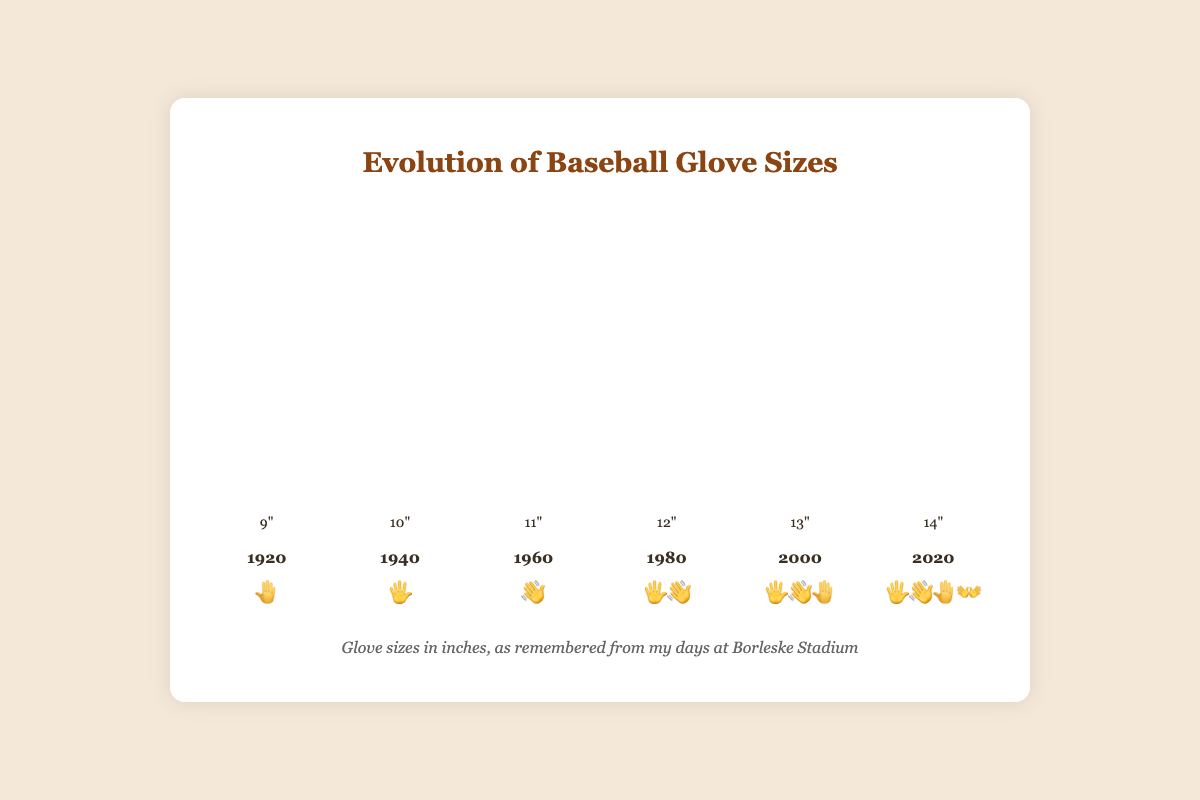Which year has the smallest glove size? The bar representing the year 1920 has the smallest height among all other bars, and the glove size is labeled as 9 inches.
Answer: 1920 What is the range of glove sizes shown in the chart from the smallest to the largest? The smallest glove size is 9 inches (1920) and the largest is 14 inches (2020). The range is calculated as 14 - 9.
Answer: 5 inches In which decade did the glove size reach 12 inches? The glove size reached 12 inches in the decade of 1980, as shown by the bar labeled with a height corresponding to 12 inches.
Answer: 1980 How many years are displayed on the chart? Counting the individual major year labels, the chart shows data for the years 1920, 1940, 1960, 1980, 2000, and 2020.
Answer: 6 years What does the glove size reach in the year 2020? The glove size in 2020 is marked on the bar, which reaches 14 inches, and is shown with the emoji combination 🖐️👋🤚👐.
Answer: 14 inches Which year has a glove size of 11 inches? The bar representing the year 1960 has a height corresponding to 11 inches, and the emoji near it is 👋.
Answer: 1960 How much did the glove size increase from 1940 to 1960? The glove size increased from 10 inches in 1940 to 11 inches in 1960. The increase is calculated as 11 - 10.
Answer: 1 inch Which emoji combination represents the glove size in the year 2000? The year 2000 is associated with the glove size of 13 inches, which is represented by the emoji combination 🖐️👋🤚.
Answer: 🖐️👋🤚 Compare the glove sizes of the years 1980 and 2000. Which one is larger and by how much? In 1980, the glove size is 12 inches, while in 2000, it is 13 inches. The difference is calculated as 13 - 12. Therefore, the glove size in 2000 is larger by 1 inch.
Answer: 2000 by 1 inch Considering the data points available, what is the average glove size from 1920 to 2020? The glove sizes are: 9, 10, 11, 12, 13, and 14. Sum these values (9 + 10 + 11 + 12 + 13 + 14) to get 69. Then, divide by the number of data points, 6. The calculation is 69 / 6.
Answer: 11.5 inches 